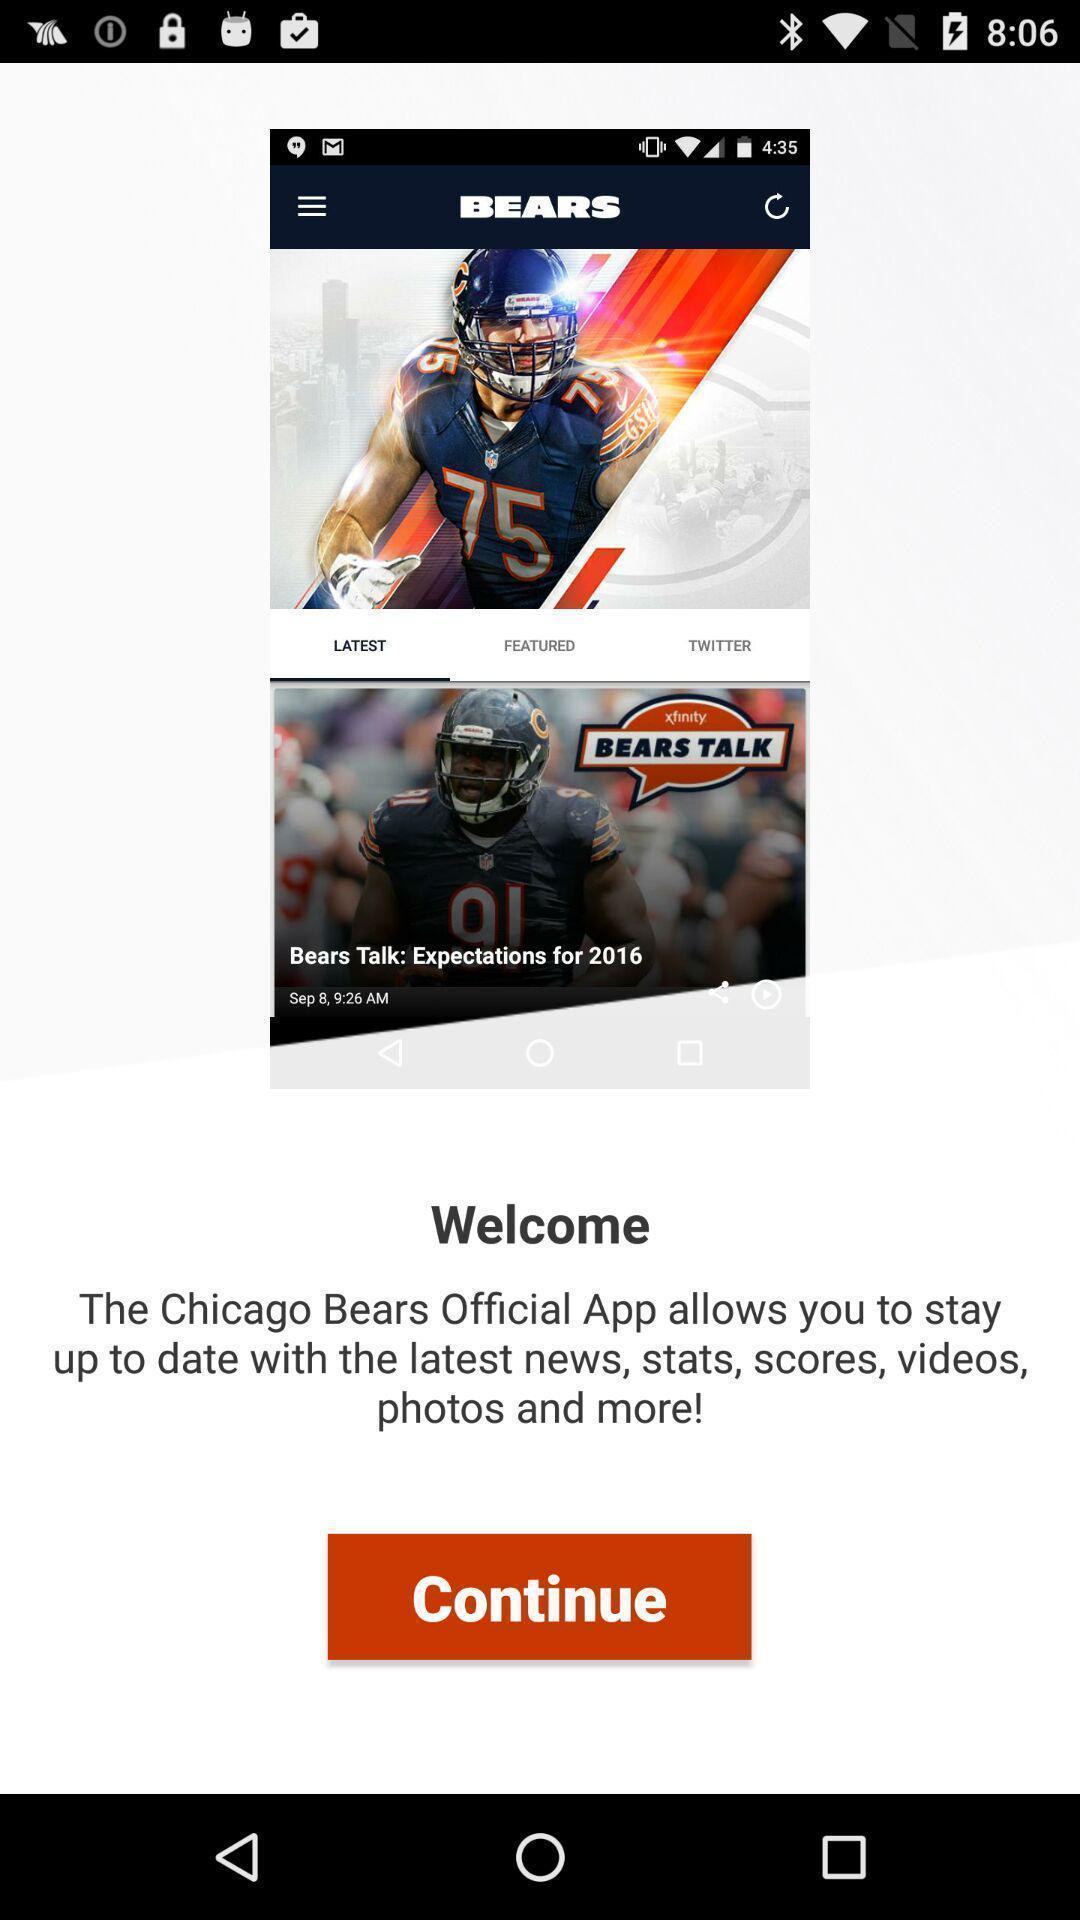Summarize the information in this screenshot. Welcome page of official mobile application. 